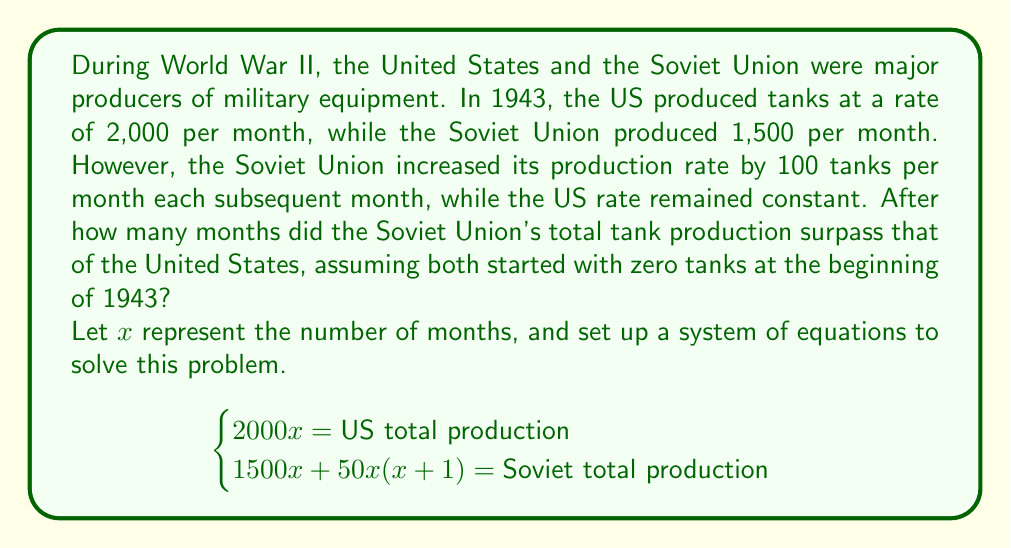Give your solution to this math problem. To solve this problem, we need to set up and solve a system of equations:

1) Let's define our variables:
   $x$ = number of months
   
2) Set up the equations:
   US total production: $2000x$
   Soviet total production: $1500x + 50x(x+1)$

3) For the Soviet Union to surpass the US, we set up the inequality:
   $1500x + 50x(x+1) > 2000x$

4) Simplify the left side of the inequality:
   $1500x + 50x^2 + 50x > 2000x$
   $50x^2 + 1550x > 2000x$
   $50x^2 - 450x > 0$

5) Factor out $50x$:
   $50x(x - 9) > 0$

6) For this inequality to be true, both factors must be positive (since we're dealing with positive time):
   $x > 0$ and $x > 9$

7) The smallest integer value of $x$ that satisfies both conditions is 10.

Therefore, after 10 months, the Soviet Union's total tank production surpassed that of the United States.

To verify:
US production after 10 months: $2000 * 10 = 20,000$ tanks
Soviet production after 10 months: $1500 * 10 + 50 * 10 * 11 = 20,500$ tanks
Answer: The Soviet Union's total tank production surpassed that of the United States after 10 months. 